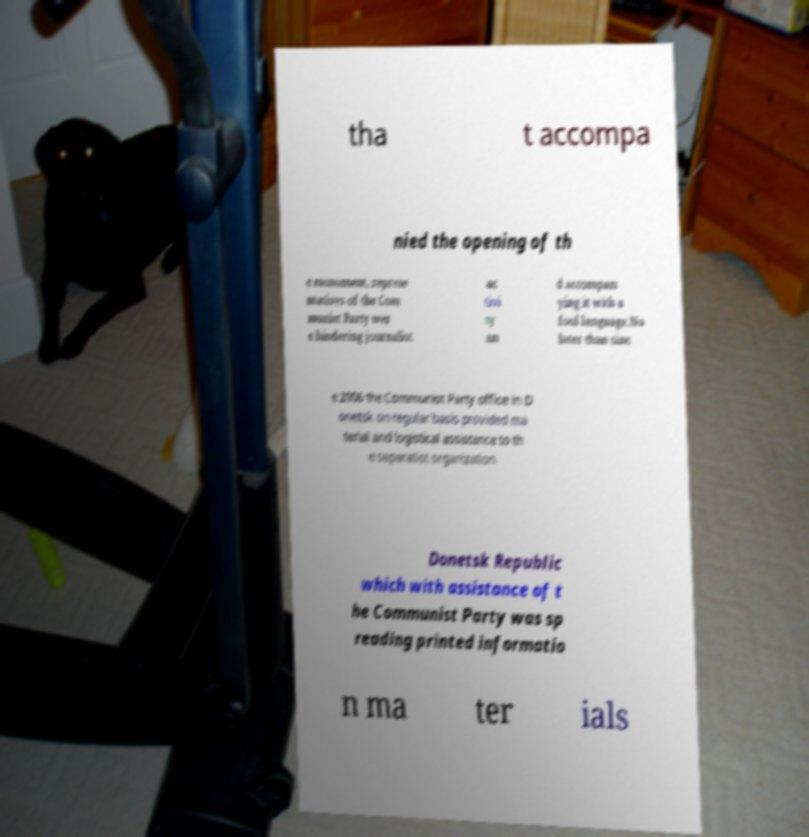There's text embedded in this image that I need extracted. Can you transcribe it verbatim? tha t accompa nied the opening of th e monument, represe ntatives of the Com munist Party wer e hindering journalist ac tivi ty an d accompan ying it with a foul language.No later than sinc e 2006 the Communist Party office in D onetsk on regular basis provided ma terial and logistical assistance to th e separatist organization Donetsk Republic which with assistance of t he Communist Party was sp reading printed informatio n ma ter ials 